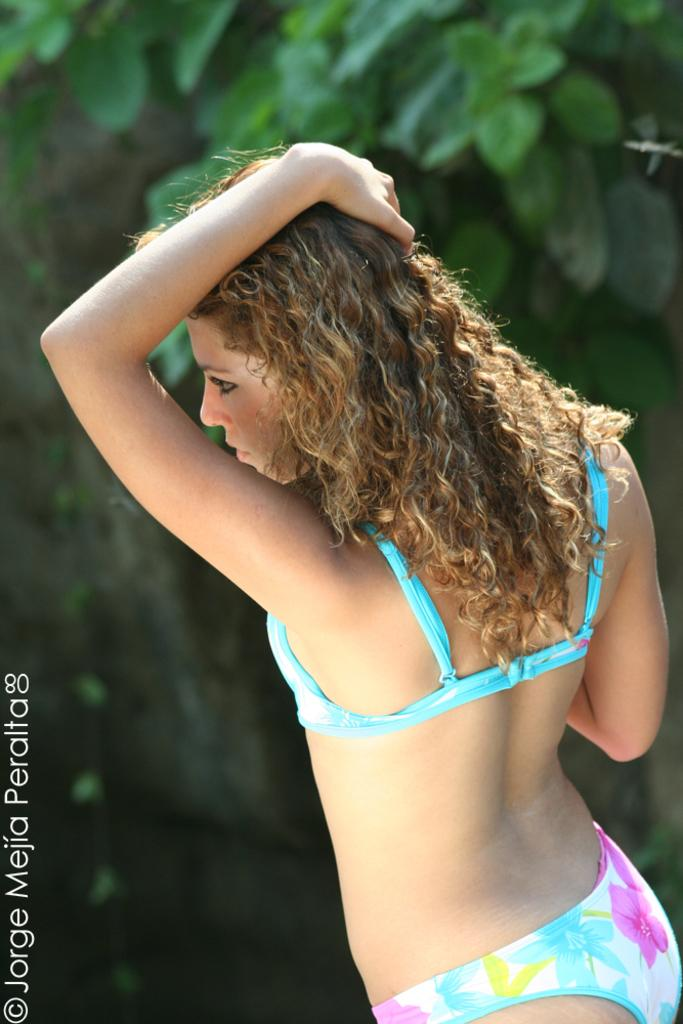What is the main subject of the image? There is a woman in the middle of the image. What is the woman doing in the image? The woman is placing a hand on her head and watching something. What can be seen in the background of the image? There are trees in the background of the image. Is there any additional information about the image? Yes, there is a watermark on the bottom left of the image. Reasoning: Let'g: Let's think step by step in order to produce the conversation. We start by identifying the main subject of the image, which is the woman. Then, we describe her actions and what she is watching. Next, we mention the background of the image, which includes trees. Finally, we acknowledge the presence of a watermark, which provides additional information about the image. Absurd Question/Answer: What type of country is depicted in the image? There is no country depicted in the image; it features a woman with her hand on her head and trees in the background. Is the woman wearing a chain around her wrist in the image? There is no chain visible around the woman's wrist in the image. 